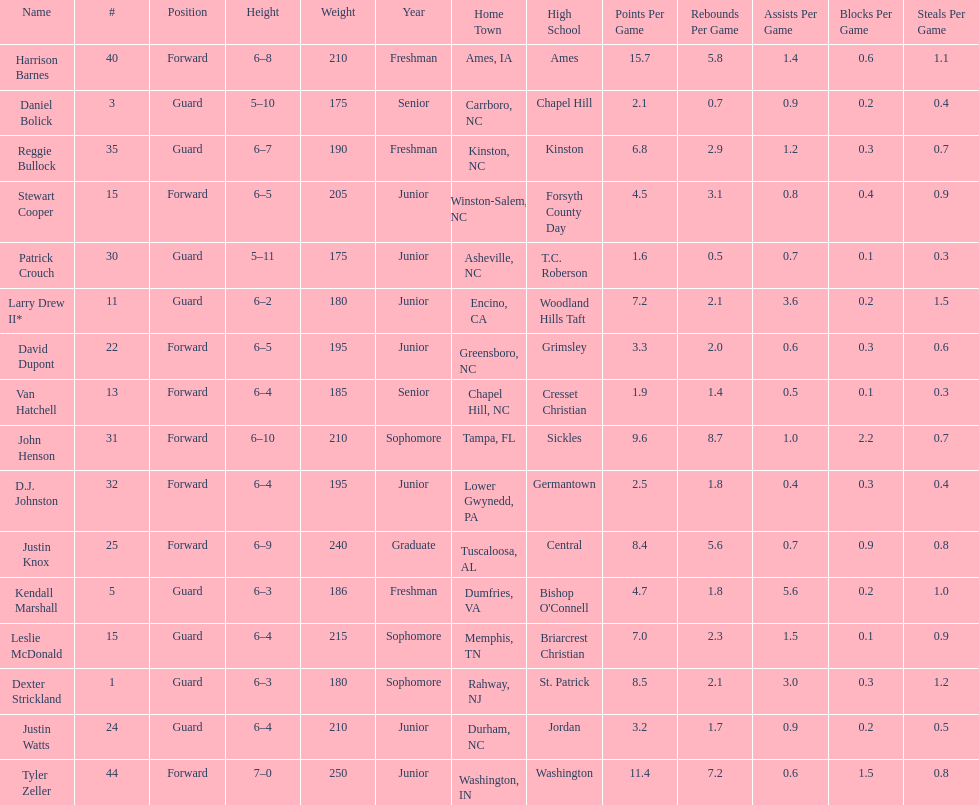What was the number of freshmen on the team? 3. 